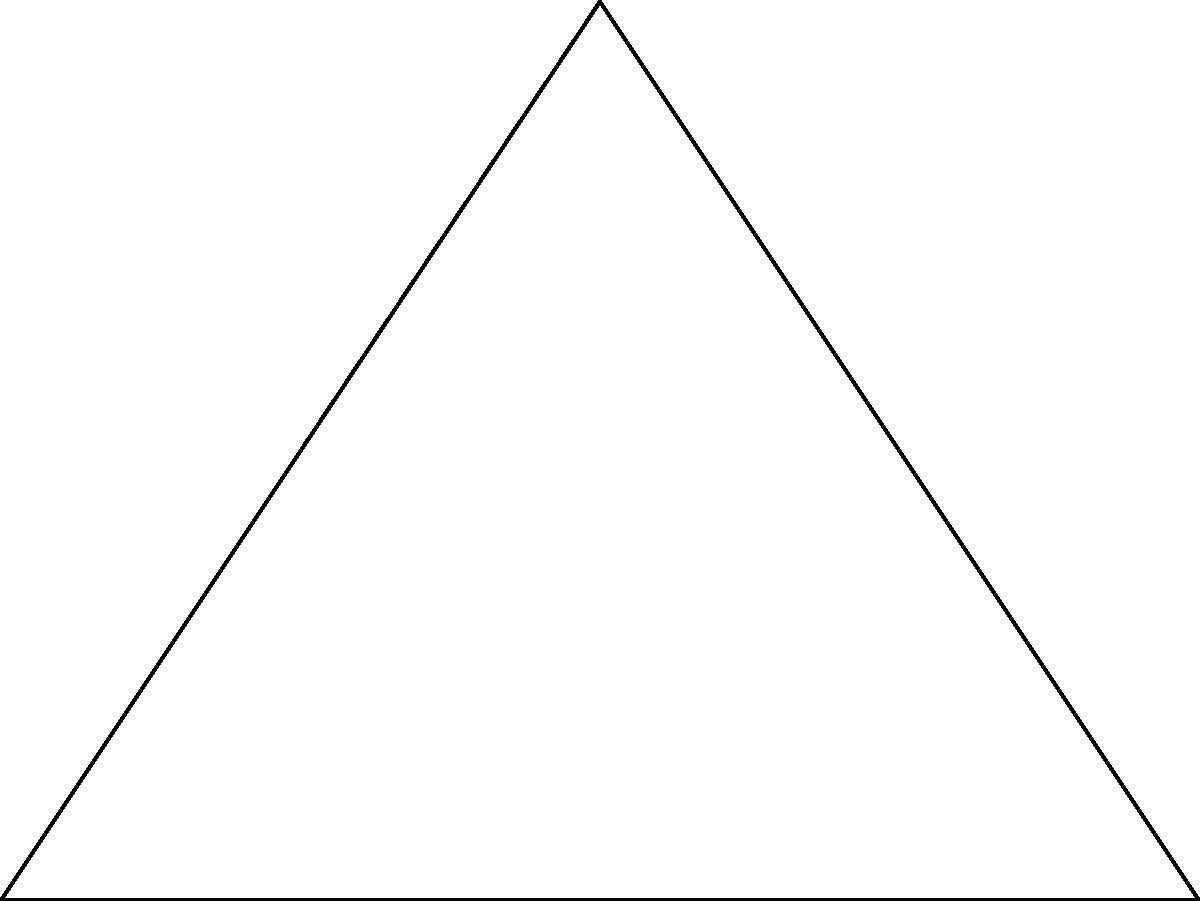In the diagram of a simplified French medieval castle fortification, angle ACB is a right angle (90°), and angle CAB is 60°. What is the measure of angle ABC (represented by $\alpha$)? To find the measure of angle ABC ($\alpha$), we can follow these steps:

1. Recall that the sum of angles in a triangle is always 180°.

2. We are given two angles in the triangle:
   - Angle ACB = 90° (right angle)
   - Angle CAB = 60°

3. Let's call the measure of angle ABC as $\alpha$.

4. We can set up an equation based on the sum of angles in a triangle:
   $90° + 60° + \alpha = 180°$

5. Simplify the left side of the equation:
   $150° + \alpha = 180°$

6. Subtract 150° from both sides:
   $\alpha = 180° - 150°$

7. Solve for $\alpha$:
   $\alpha = 30°$

Therefore, the measure of angle ABC ($\alpha$) is 30°.
Answer: 30° 